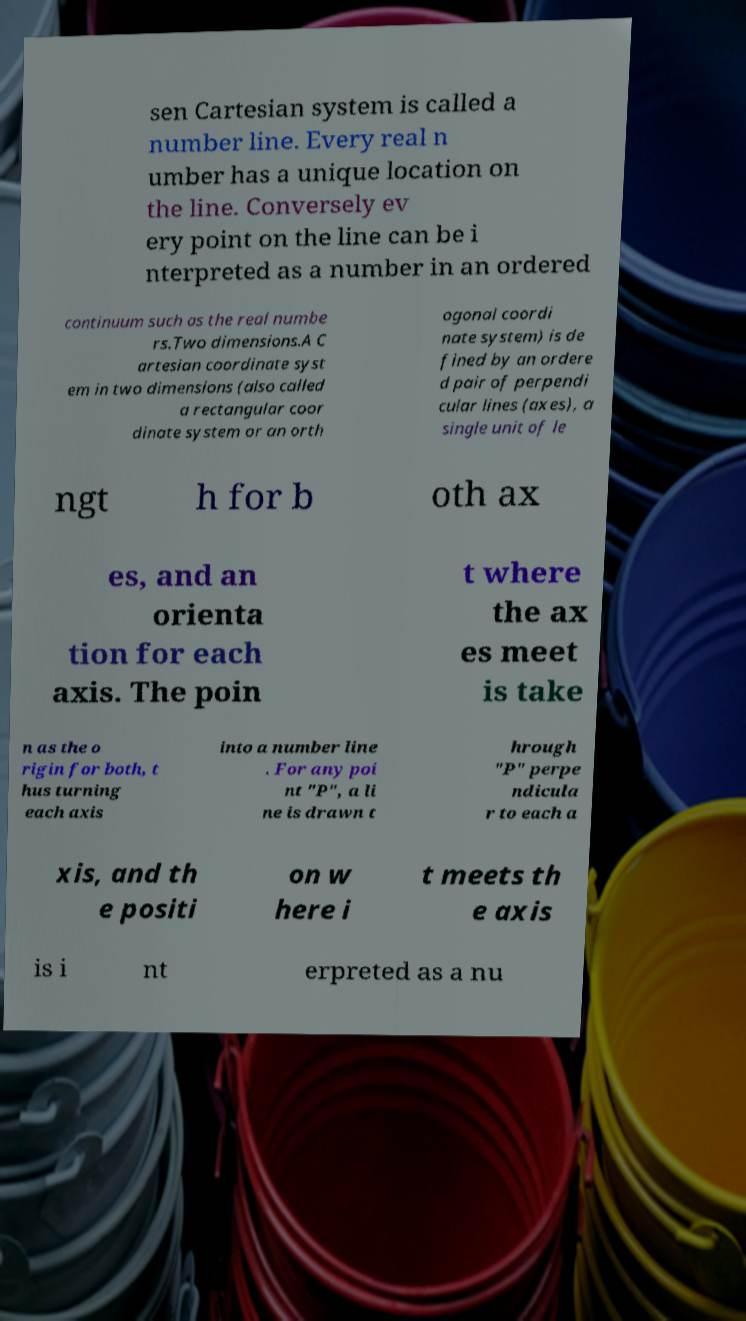There's text embedded in this image that I need extracted. Can you transcribe it verbatim? sen Cartesian system is called a number line. Every real n umber has a unique location on the line. Conversely ev ery point on the line can be i nterpreted as a number in an ordered continuum such as the real numbe rs.Two dimensions.A C artesian coordinate syst em in two dimensions (also called a rectangular coor dinate system or an orth ogonal coordi nate system) is de fined by an ordere d pair of perpendi cular lines (axes), a single unit of le ngt h for b oth ax es, and an orienta tion for each axis. The poin t where the ax es meet is take n as the o rigin for both, t hus turning each axis into a number line . For any poi nt "P", a li ne is drawn t hrough "P" perpe ndicula r to each a xis, and th e positi on w here i t meets th e axis is i nt erpreted as a nu 